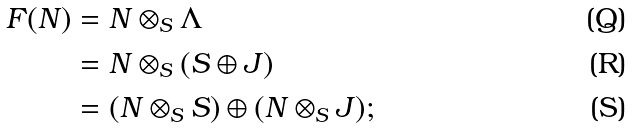<formula> <loc_0><loc_0><loc_500><loc_500>F ( N ) & = N \otimes _ { S } \Lambda \\ & = N \otimes _ { S } ( S \oplus J ) \\ & = ( N \otimes _ { S } S ) \oplus ( N \otimes _ { S } J ) ;</formula> 